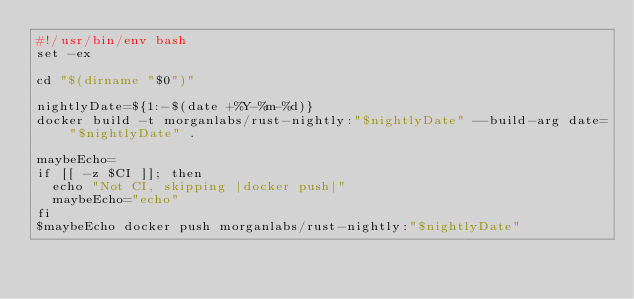Convert code to text. <code><loc_0><loc_0><loc_500><loc_500><_Bash_>#!/usr/bin/env bash
set -ex

cd "$(dirname "$0")"

nightlyDate=${1:-$(date +%Y-%m-%d)}
docker build -t morganlabs/rust-nightly:"$nightlyDate" --build-arg date="$nightlyDate" .

maybeEcho=
if [[ -z $CI ]]; then
  echo "Not CI, skipping |docker push|"
  maybeEcho="echo"
fi
$maybeEcho docker push morganlabs/rust-nightly:"$nightlyDate"
</code> 